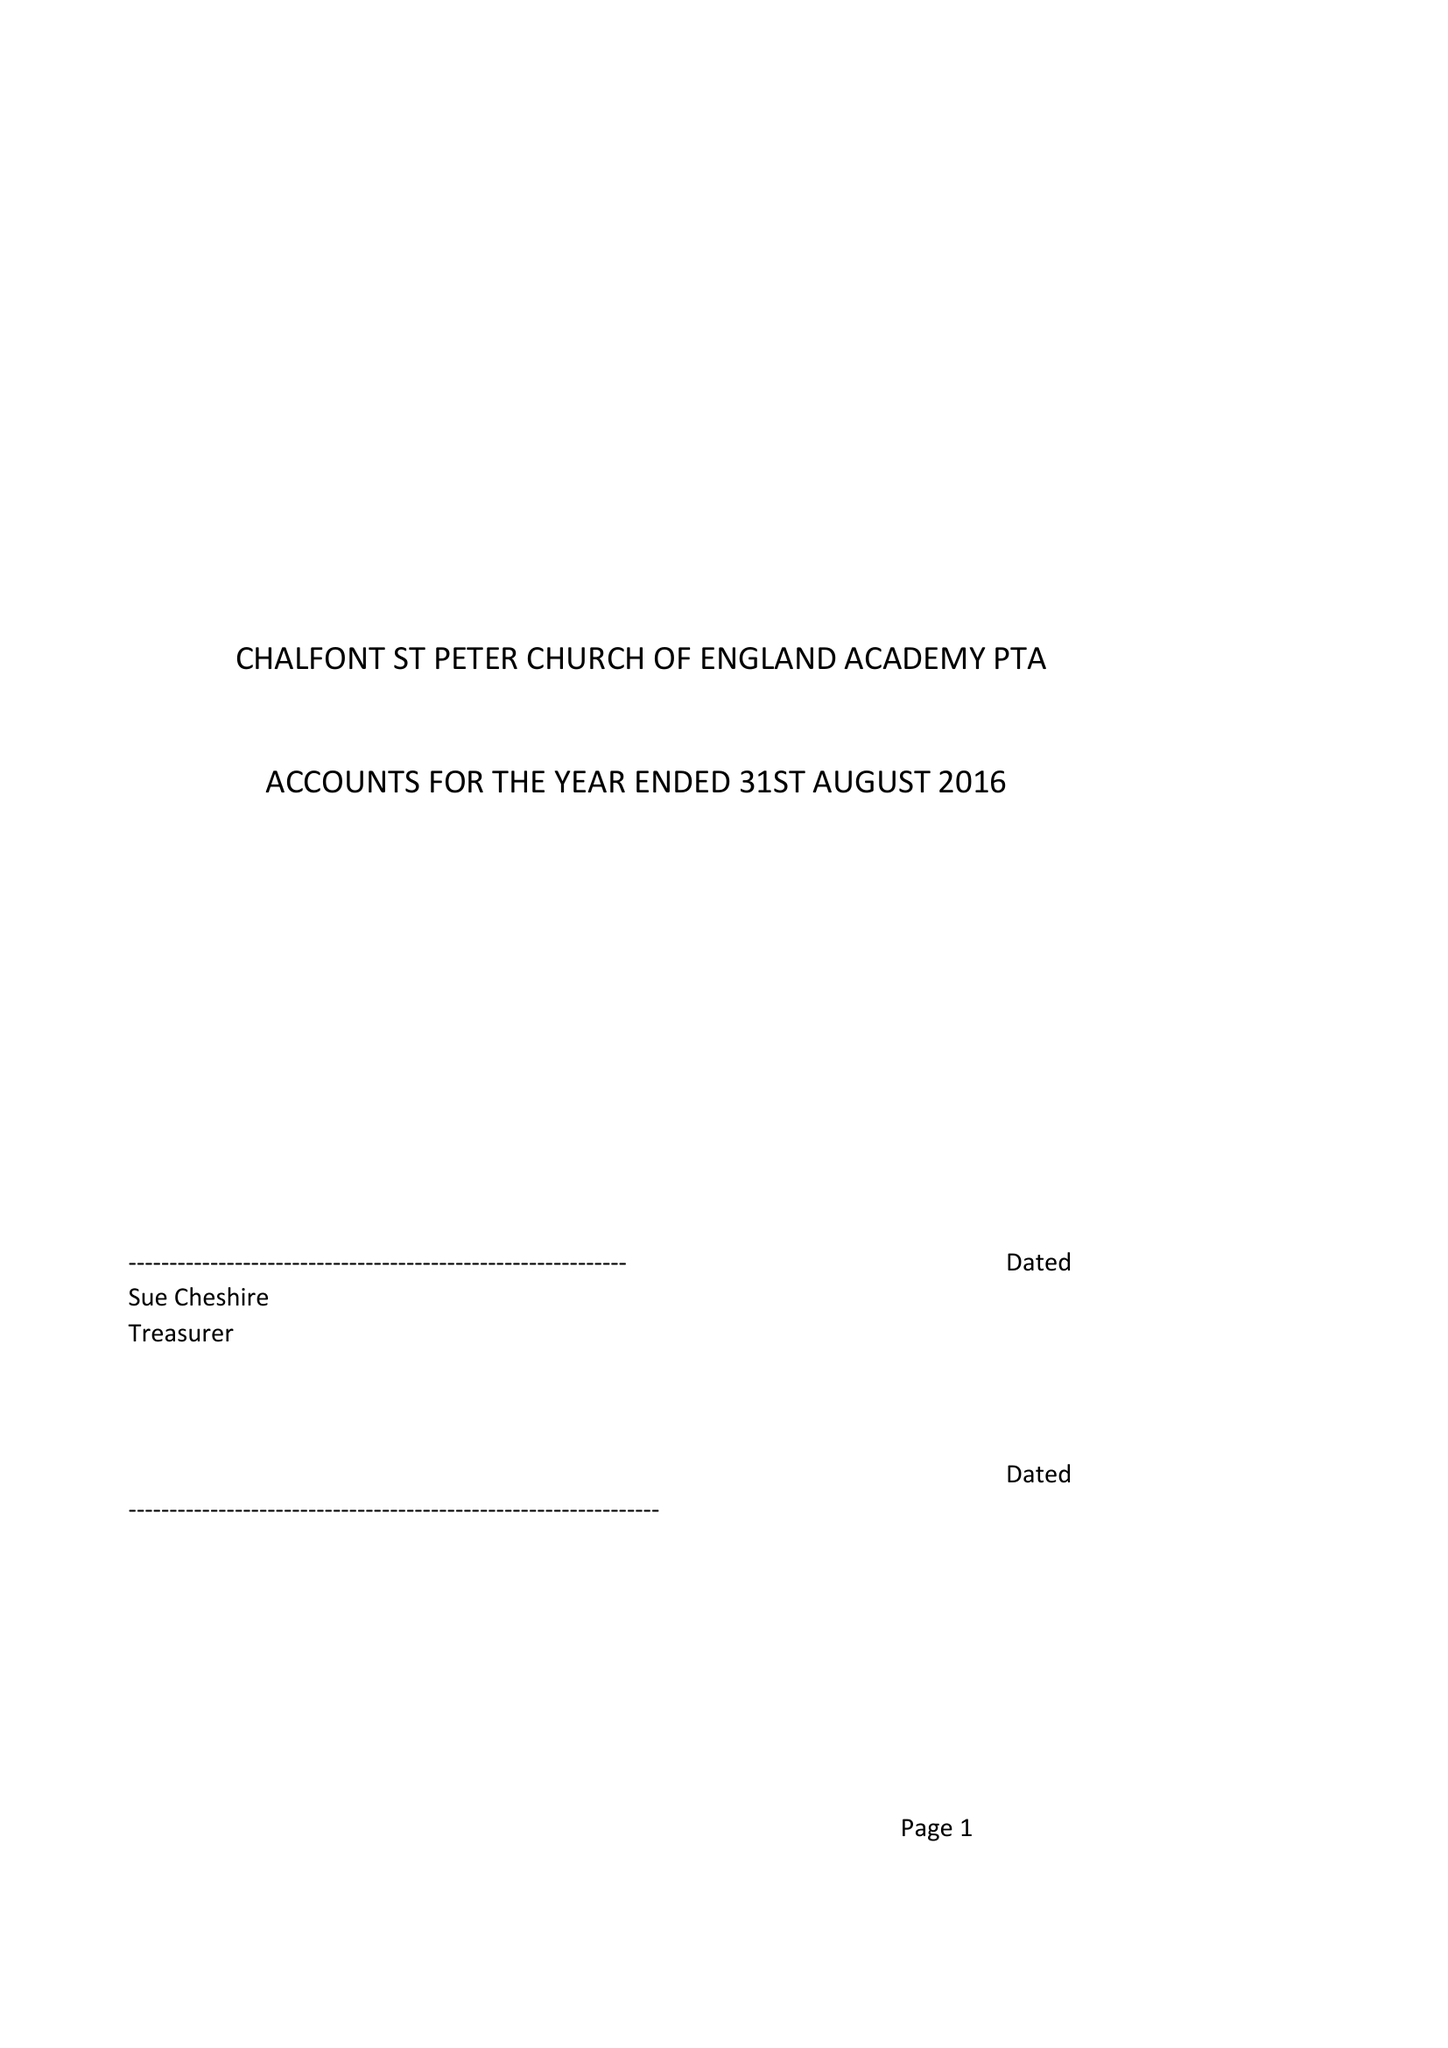What is the value for the report_date?
Answer the question using a single word or phrase. 2016-08-31 